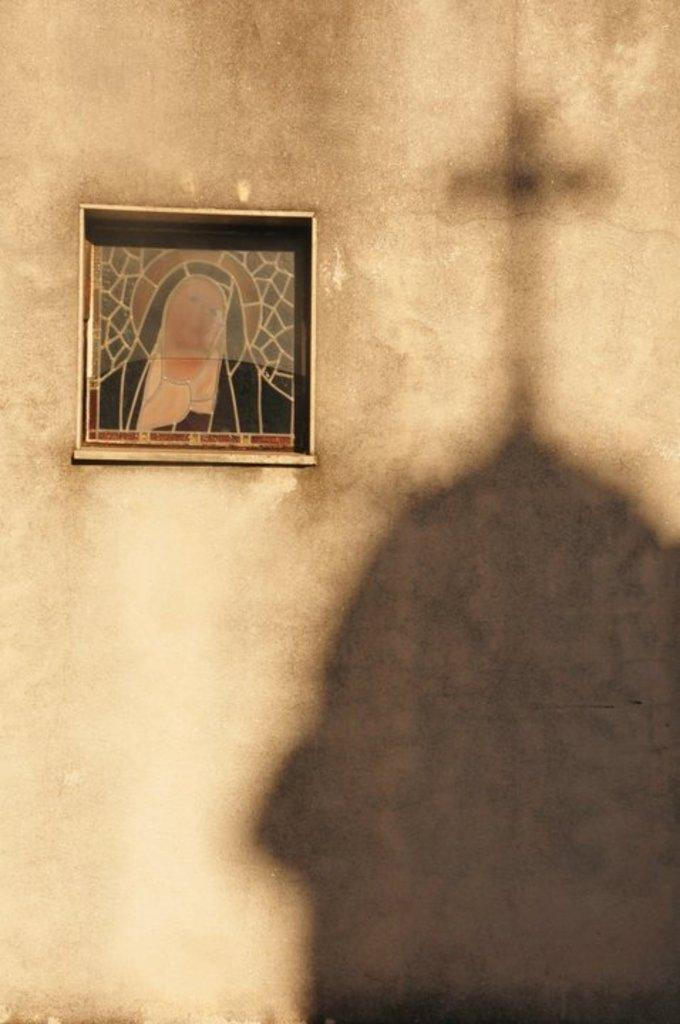What is hanging on the wall in the image? There is a frame on the wall in the image. What can be seen as a shadow on the wall in the image? There is a shadow of a cross on the wall in the image. What type of competition is taking place in the image? There is no competition present in the image. What color is the skirt hanging on the wall in the image? There is no skirt present in the image. 